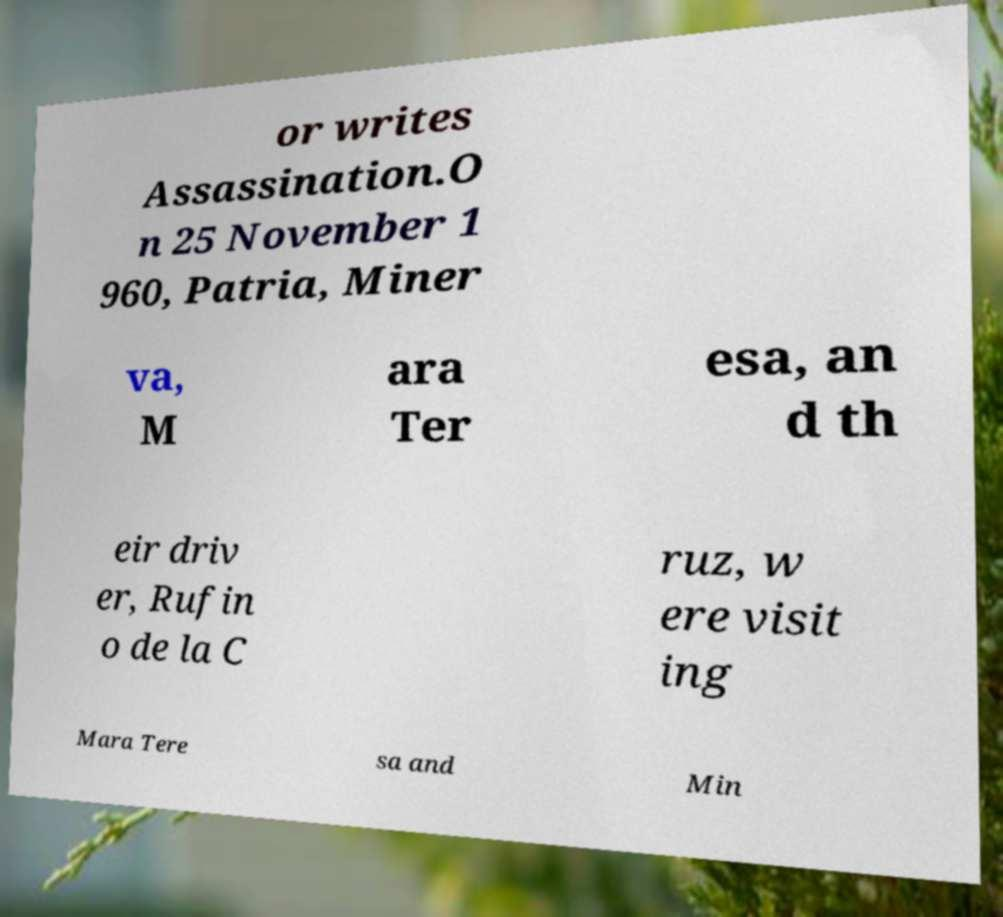Could you extract and type out the text from this image? or writes Assassination.O n 25 November 1 960, Patria, Miner va, M ara Ter esa, an d th eir driv er, Rufin o de la C ruz, w ere visit ing Mara Tere sa and Min 